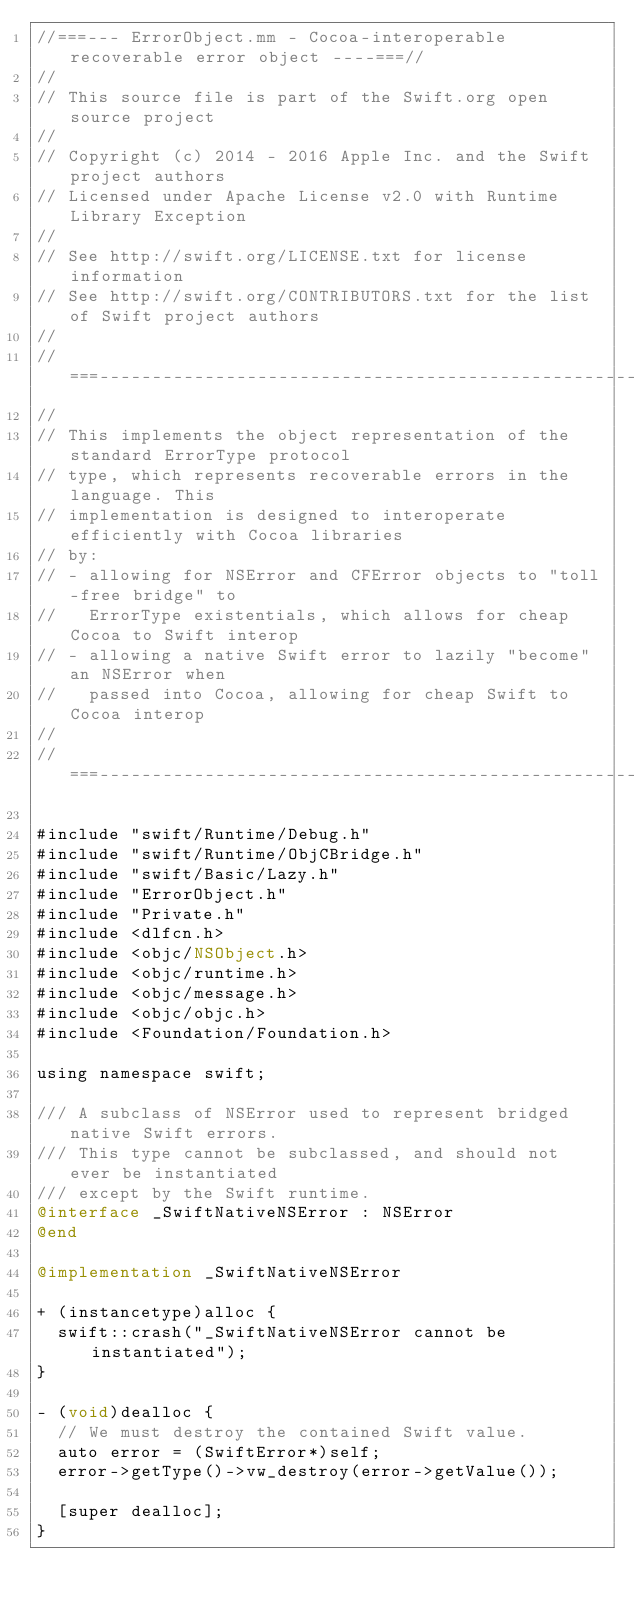<code> <loc_0><loc_0><loc_500><loc_500><_ObjectiveC_>//===--- ErrorObject.mm - Cocoa-interoperable recoverable error object ----===//
//
// This source file is part of the Swift.org open source project
//
// Copyright (c) 2014 - 2016 Apple Inc. and the Swift project authors
// Licensed under Apache License v2.0 with Runtime Library Exception
//
// See http://swift.org/LICENSE.txt for license information
// See http://swift.org/CONTRIBUTORS.txt for the list of Swift project authors
//
//===----------------------------------------------------------------------===//
//
// This implements the object representation of the standard ErrorType protocol
// type, which represents recoverable errors in the language. This
// implementation is designed to interoperate efficiently with Cocoa libraries
// by:
// - allowing for NSError and CFError objects to "toll-free bridge" to
//   ErrorType existentials, which allows for cheap Cocoa to Swift interop
// - allowing a native Swift error to lazily "become" an NSError when
//   passed into Cocoa, allowing for cheap Swift to Cocoa interop
//
//===----------------------------------------------------------------------===//

#include "swift/Runtime/Debug.h"
#include "swift/Runtime/ObjCBridge.h"
#include "swift/Basic/Lazy.h"
#include "ErrorObject.h"
#include "Private.h"
#include <dlfcn.h>
#include <objc/NSObject.h>
#include <objc/runtime.h>
#include <objc/message.h>
#include <objc/objc.h>
#include <Foundation/Foundation.h>

using namespace swift;

/// A subclass of NSError used to represent bridged native Swift errors.
/// This type cannot be subclassed, and should not ever be instantiated
/// except by the Swift runtime.
@interface _SwiftNativeNSError : NSError
@end

@implementation _SwiftNativeNSError

+ (instancetype)alloc {
  swift::crash("_SwiftNativeNSError cannot be instantiated");
}

- (void)dealloc {
  // We must destroy the contained Swift value.
  auto error = (SwiftError*)self;
  error->getType()->vw_destroy(error->getValue());

  [super dealloc];
}
</code> 